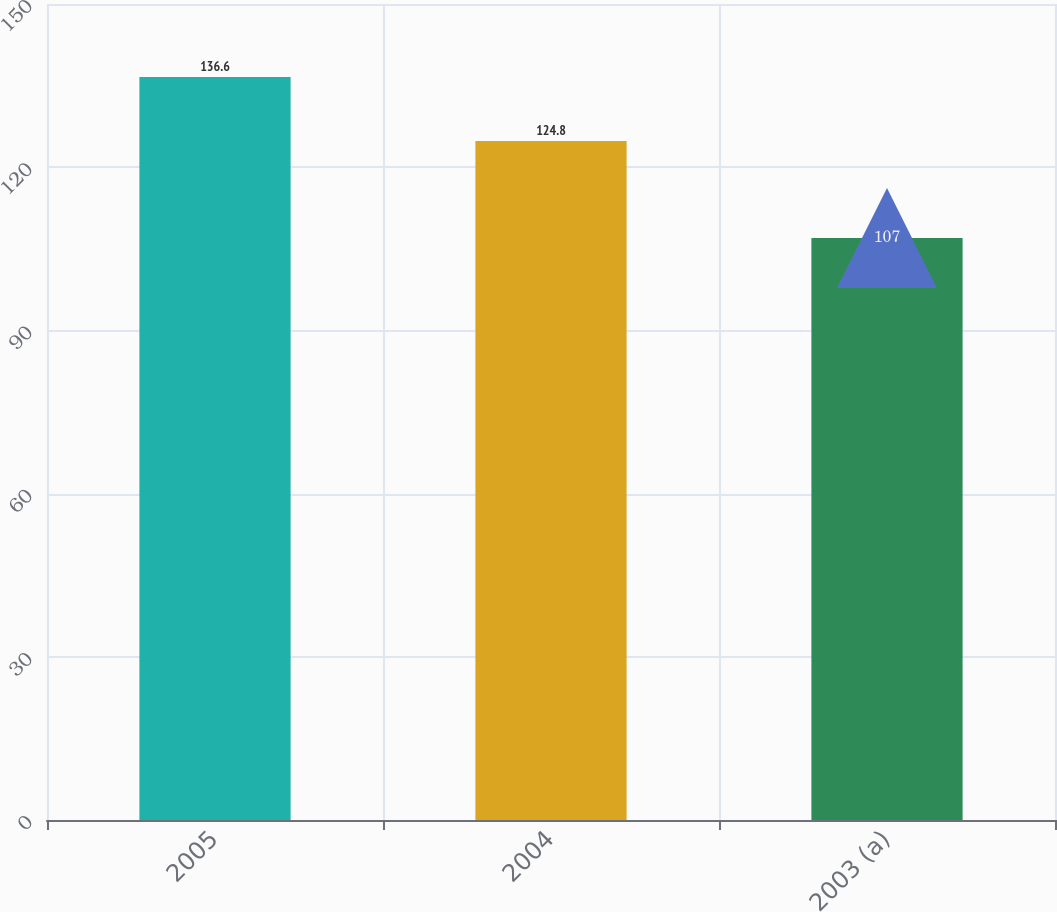<chart> <loc_0><loc_0><loc_500><loc_500><bar_chart><fcel>2005<fcel>2004<fcel>2003 (a)<nl><fcel>136.6<fcel>124.8<fcel>107<nl></chart> 